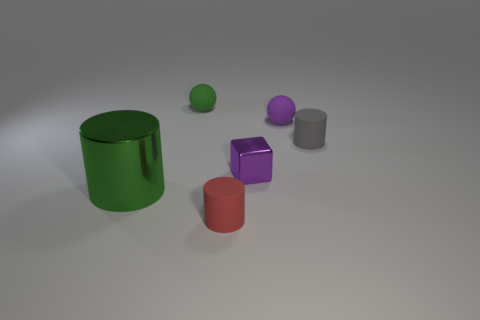Add 2 large yellow matte objects. How many objects exist? 8 Subtract all spheres. How many objects are left? 4 Add 4 green things. How many green things exist? 6 Subtract 0 gray spheres. How many objects are left? 6 Subtract all purple matte objects. Subtract all tiny blue matte cubes. How many objects are left? 5 Add 2 small cylinders. How many small cylinders are left? 4 